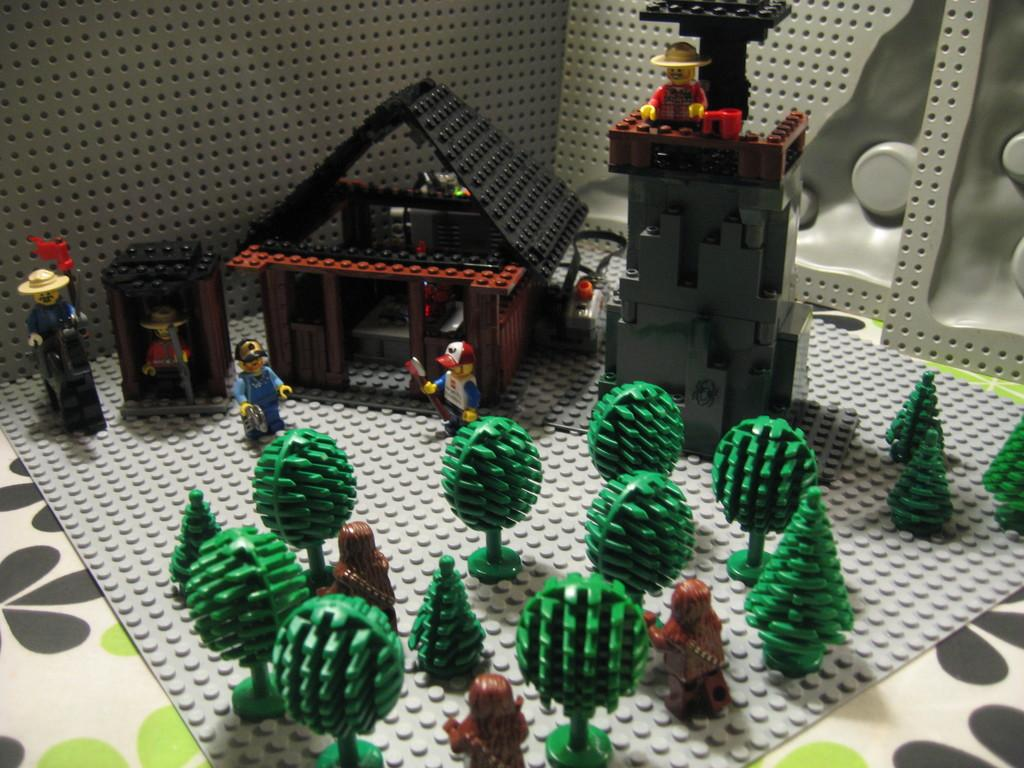What is the main subject of the image? The main subject of the image is a model. What elements are included in the model? The model contains trees, a man, houses with roofs and walls, and machines. What is the color of the background in the image? The background of the image is grey. What type of disease can be seen affecting the trees in the model? There is no disease affecting the trees in the model; the trees appear to be healthy. What type of harmony is present between the man and the machines in the model? There is no mention of harmony between the man and the machines in the model; the image only shows their presence in the scene. 